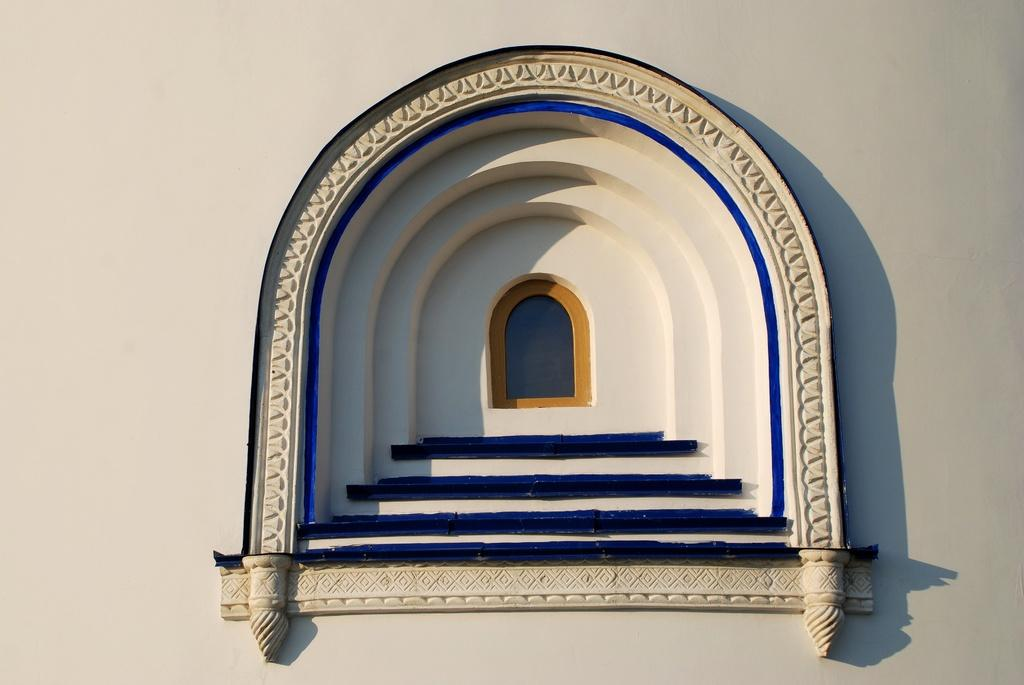What type of window is featured in the image? There is an arch window in the image. Where is the arch window located? The arch window is on a wall. How many drawers are visible in the image? There are no drawers present in the image. What is the purpose of the observation deck in the image? There is no observation deck present in the image. 